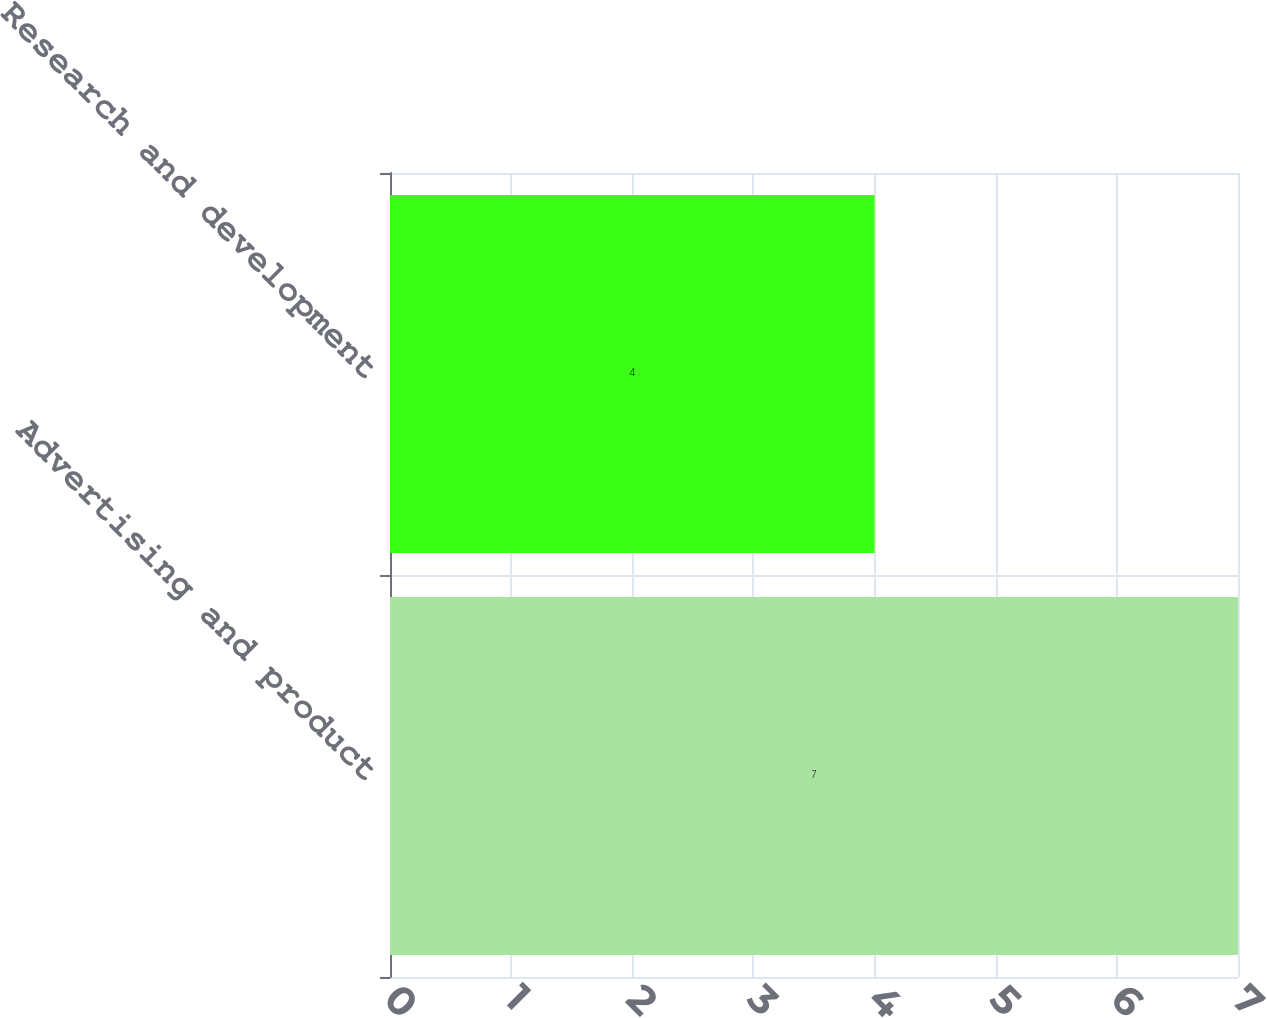<chart> <loc_0><loc_0><loc_500><loc_500><bar_chart><fcel>Advertising and product<fcel>Research and development<nl><fcel>7<fcel>4<nl></chart> 